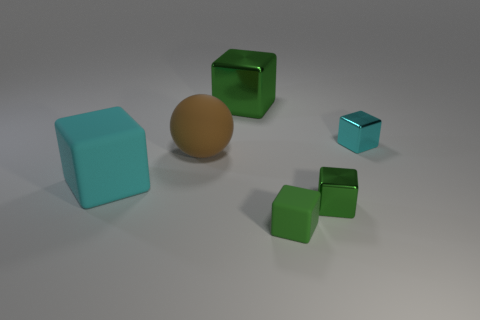How many green cubes must be subtracted to get 1 green cubes? 2 Subtract all purple cylinders. How many green cubes are left? 3 Subtract all green rubber blocks. How many blocks are left? 4 Subtract all brown blocks. Subtract all blue cylinders. How many blocks are left? 5 Add 3 small green metallic cylinders. How many objects exist? 9 Subtract all balls. How many objects are left? 5 Add 4 brown matte things. How many brown matte things are left? 5 Add 4 large brown spheres. How many large brown spheres exist? 5 Subtract 0 brown cylinders. How many objects are left? 6 Subtract all brown balls. Subtract all tiny green things. How many objects are left? 3 